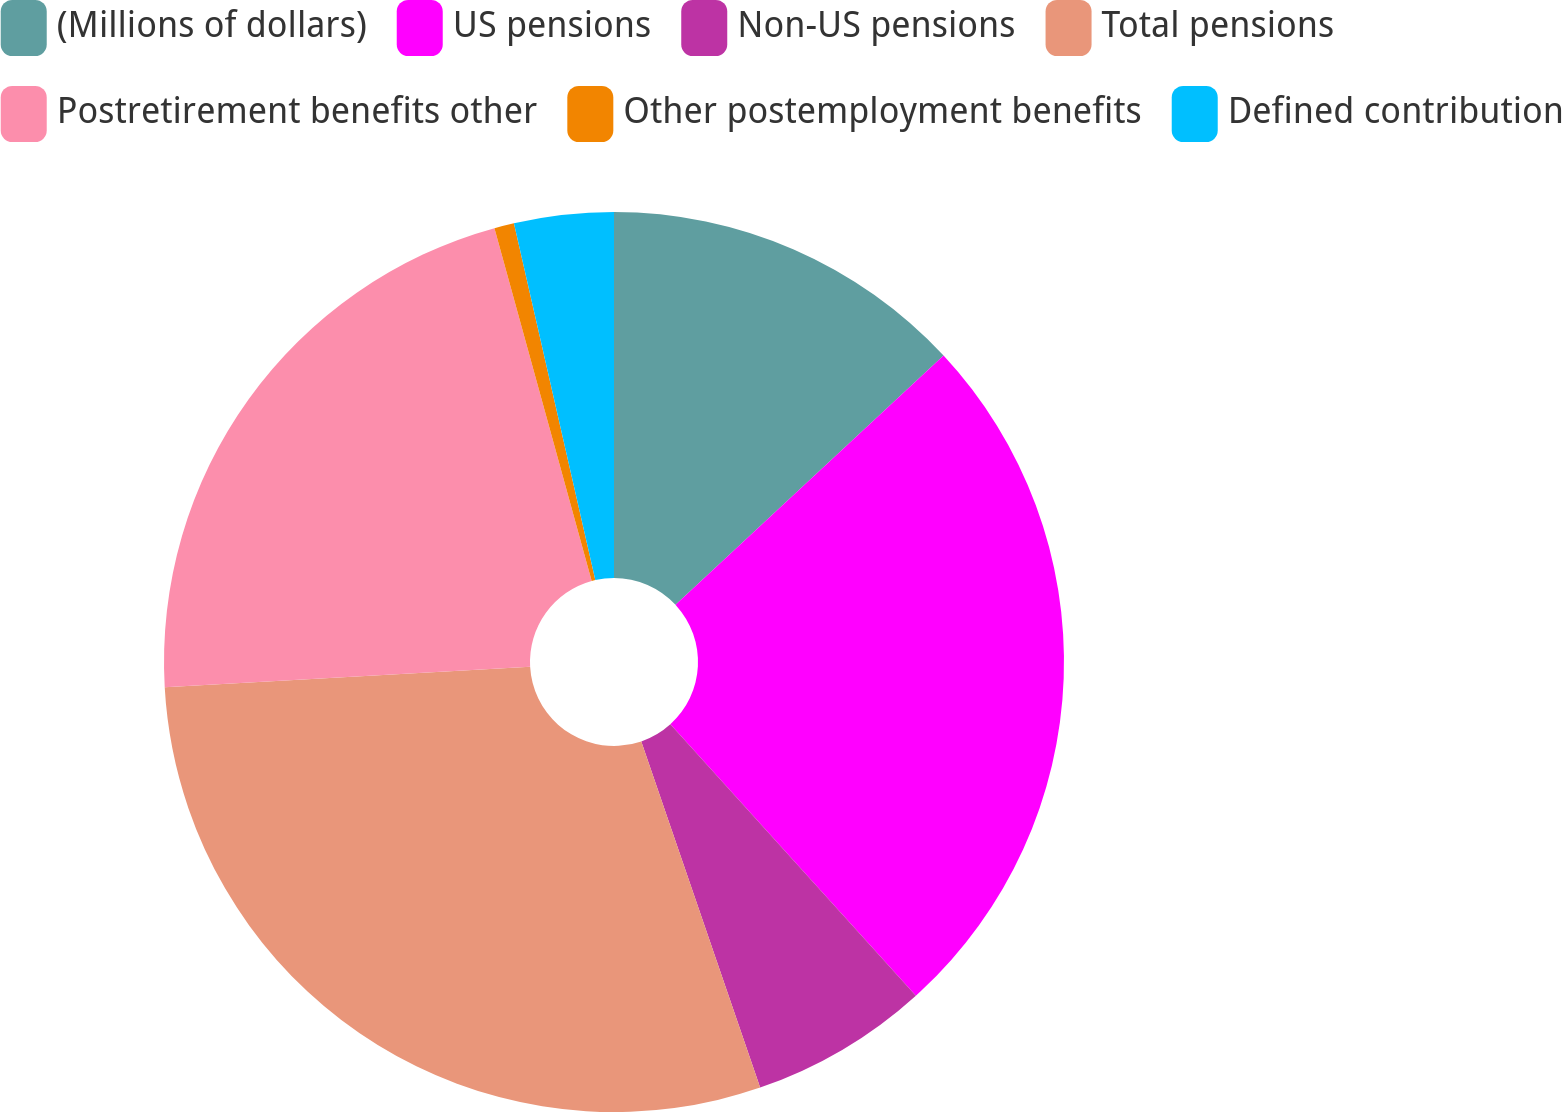<chart> <loc_0><loc_0><loc_500><loc_500><pie_chart><fcel>(Millions of dollars)<fcel>US pensions<fcel>Non-US pensions<fcel>Total pensions<fcel>Postretirement benefits other<fcel>Other postemployment benefits<fcel>Defined contribution<nl><fcel>13.08%<fcel>25.22%<fcel>6.44%<fcel>29.37%<fcel>21.62%<fcel>0.71%<fcel>3.57%<nl></chart> 